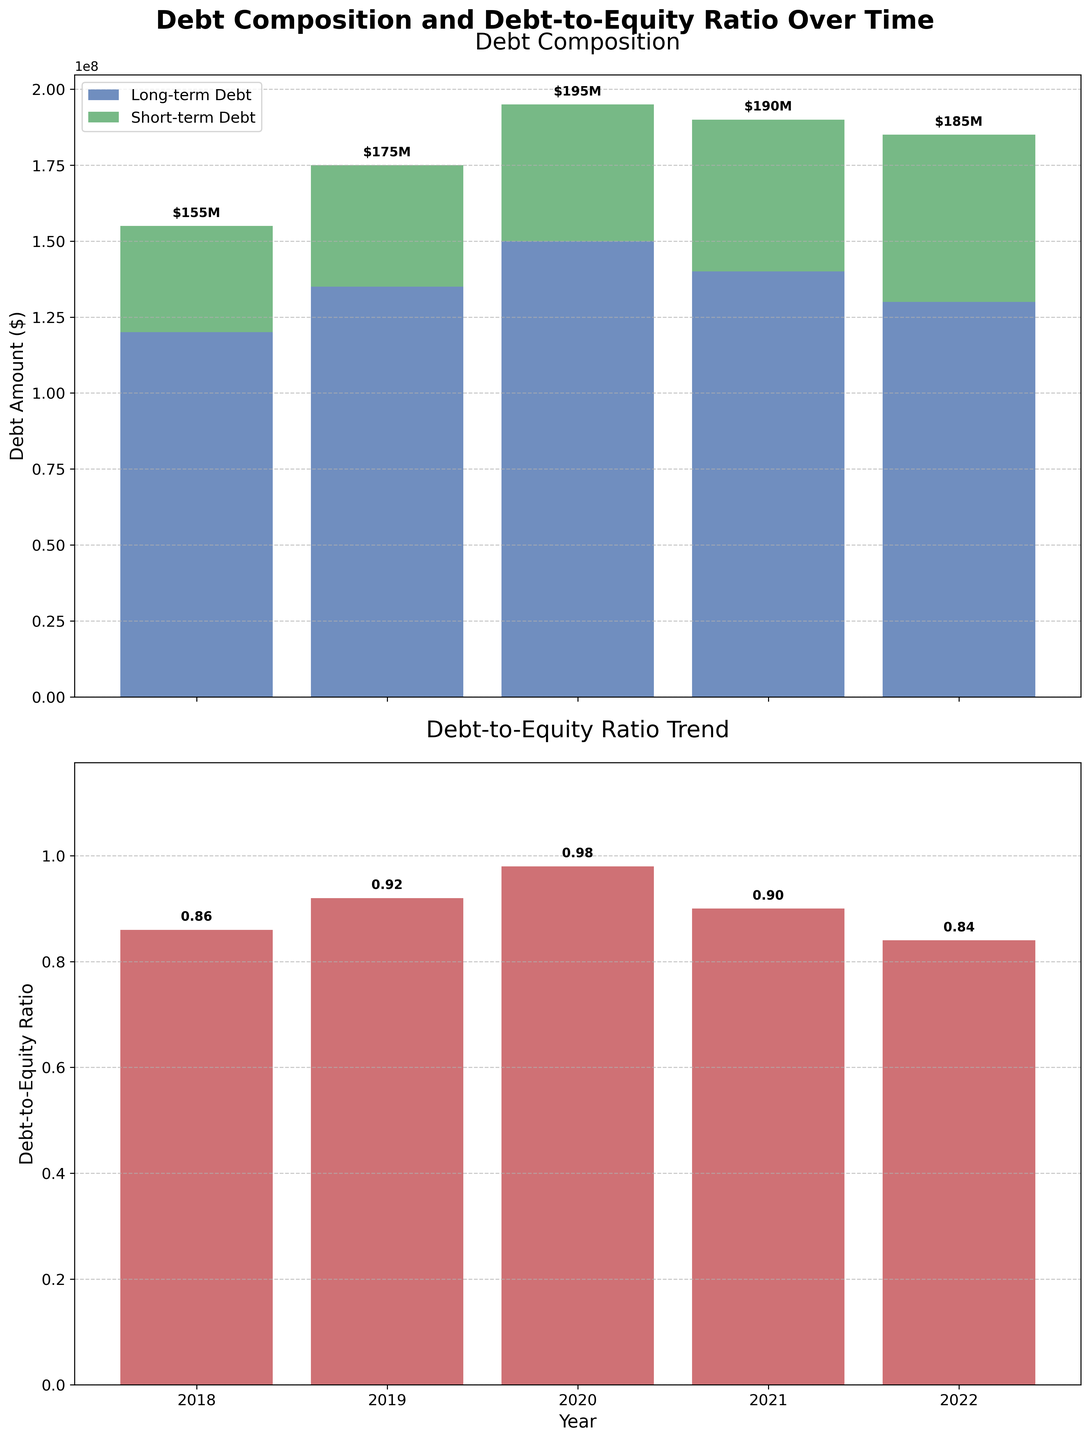What are the components of the total debt in 2020? The total debt in 2020 is composed of long-term and short-term debts. By looking at the first subplot, the long-term debt is $150,000,000, and the short-term debt is $45,000,000.
Answer: Long-term debt: $150M, Short-term debt: $45M What is the trend in the debt-to-equity ratio from 2018 to 2022? By observing the second subplot, we can see the change in the debt-to-equity ratio for each year. The ratio rises from 0.86 in 2018 to 0.98 in 2020, then declines to 0.84 by 2022.
Answer: Rises then falls Which year has the highest short-term debt? In the first subplot, the year 2022 has the highest short-term debt at $55,000,000 as shown by the topmost green bar (Short-term Debt component).
Answer: 2022 How did the total debt change from 2018 to 2019? By comparing the total debt of 2018 ($155M) and 2019 ($175M) in the first subplot, we can see that the total debt increased. The difference is $175M - $155M = $20M.
Answer: Increased by $20M Based on the plot, what happened to long-term debt from 2020 to 2022? Viewing the first subplot, the long-term debt changes are as follows: $150M (2020), $140M (2021), and $130M (2022). This shows a continuous decrease during these years.
Answer: Decreased How does the debt-to-equity ratio in 2021 compare to that in 2022? By referring to the second subplot, we see the debt-to-equity ratio in 2021 is 0.90 and in 2022 is 0.84. Hence, the ratio decreased from 2021 to 2022.
Answer: Decreased What is the difference in short-term debt between the years 2018 and 2019? The short-term debt in 2018 is $35M, and it is $40M in 2019, as seen in the first subplot. The difference is $40M - $35M = $5M.
Answer: $5M What is the combined debt (short-term and long-term) for the year 2021? Adding the long-term debt and short-term debt for 2021 from the first subplot: $140M (Long-term) + $50M (Short-term) = $190M.
Answer: $190M Which year had the lowest debt-to-equity ratio? The second subplot shows the debt-to-equity ratios for each year. The lowest value is 0.84 in 2022.
Answer: 2022 